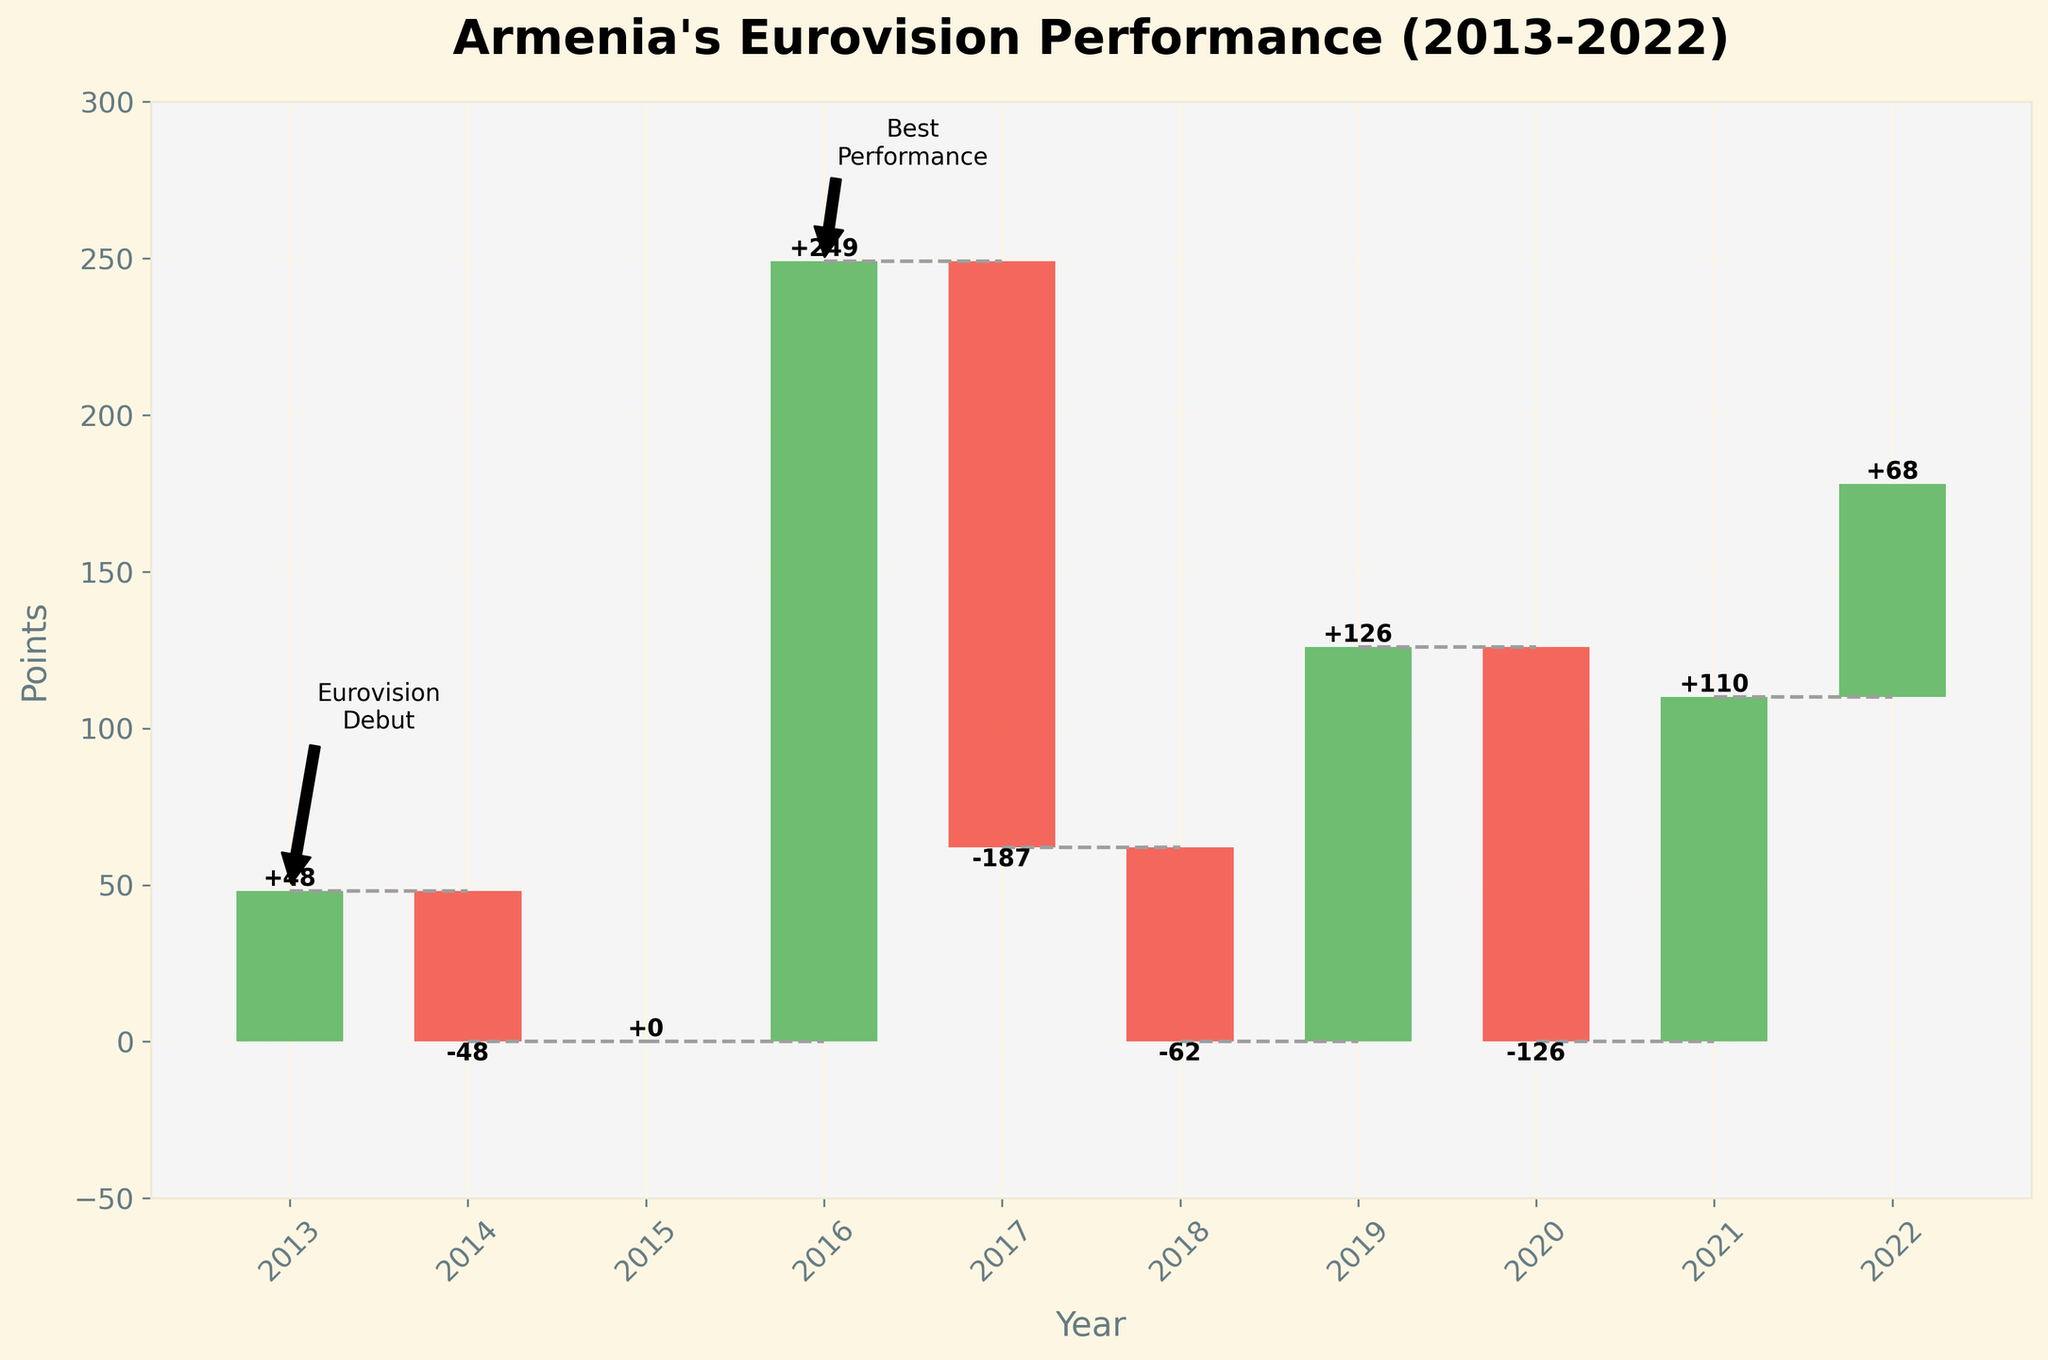What is the title of the chart? The title of the chart is displayed prominently at the top of the figure. It provides a brief description of what the chart represents. According to the figure, the title is "Armenia's Eurovision Performance (2013-2022)".
Answer: Armenia's Eurovision Performance (2013-2022) What were Armenia's Eurovision points in 2016? To find the points for 2016, look at the bar for the year 2016 in the chart. The bar's positive change combined with the cumulative value indicates the points for 2016. In 2016, the change was +249.
Answer: 249 Which year saw the highest increase in points for Armenia? To identify the year with the highest increase, compare the changes for each year. The largest positive bar indicates the highest increase. The year 2016 shows the highest increase with a change of +249 points.
Answer: 2016 How many years did Armenia end with zero cumulative points? To determine this, count the years where the cumulative points are zero. From the chart, these years are 2014, 2015, 2018, and 2020, making it 4 years in total.
Answer: 4 How does the change in points in 2021 compare to 2019? Compare the bars for the years 2021 and 2019. The change in 2021 is +110, while the change in 2019 is +126. Therefore, the change in points in 2019 is greater than in 2021.
Answer: 2019 has a higher change than 2021 What is the cumulative point change from 2019 to 2021? To find this, sum the cumulative changes of the years 2019 to 2021. For 2019 it is +126, 2020 is -126, 2021 is +110, resulting in a cumulative change of 126 - 126 + 110 = 110.
Answer: 110 What is the cumulative difference in points between 2013 and 2022? To find the cumulative difference, subtract the cumulative points of 2013 from those of 2022. In 2013 it is 48, and in 2022 it is 178. So, 178 - 48 = 130.
Answer: 130 Identify a year where there was no change in points compared to the previous year. Look for the year where the bar representing the change is zero. From the chart, the year 2015 shows no change in points with a value of 0.
Answer: 2015 Which year had the largest negative change in points? To determine this, look for the year with the largest negative bar. The year 2017 has the largest negative change with -187 points.
Answer: 2017 Between which two consecutive years did Armenia see the largest decrease in cumulative points? Find where a significant drop in cumulative points occurs by comparing the drops between consecutive years. Between 2016 and 2017, the cumulative dropped from 249 to 62, with a change of -187 points.
Answer: Between 2016 and 2017 